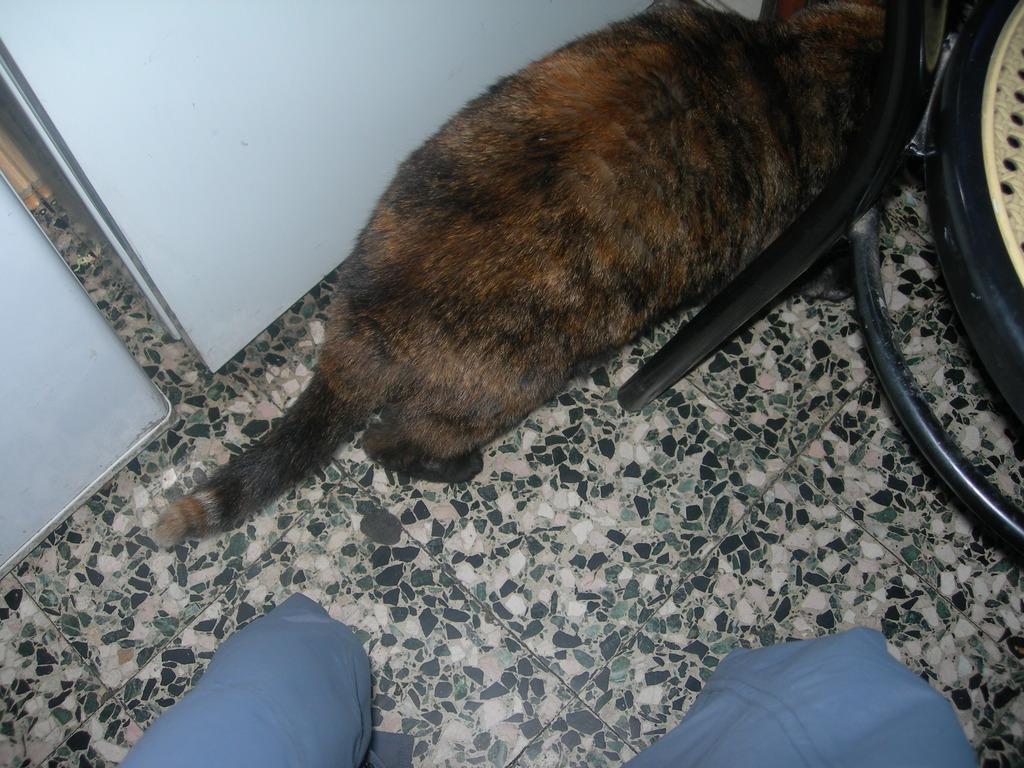In one or two sentences, can you explain what this image depicts? Here we can see a cat and chair. 